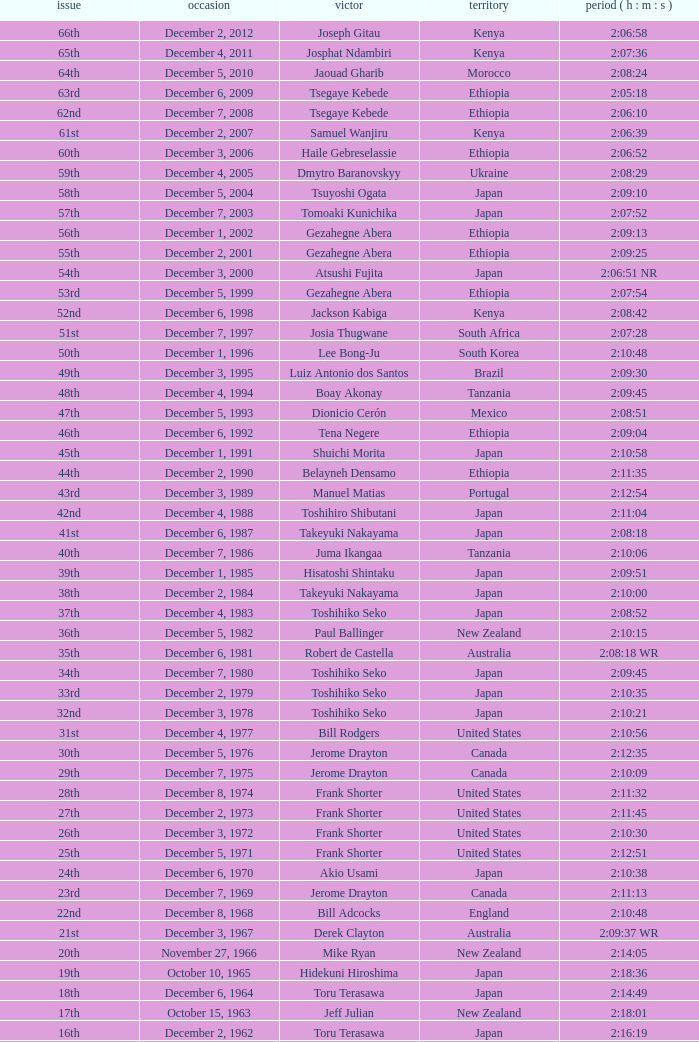On what date did Lee Bong-Ju win in 2:10:48? December 1, 1996. 